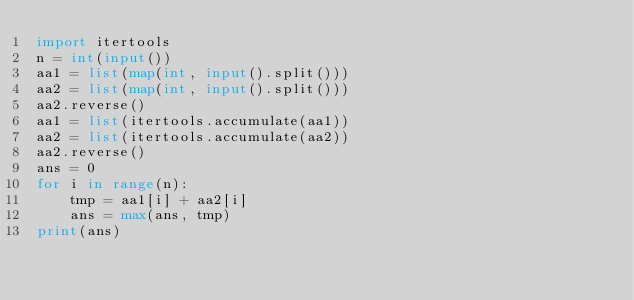Convert code to text. <code><loc_0><loc_0><loc_500><loc_500><_Python_>import itertools
n = int(input())
aa1 = list(map(int, input().split()))
aa2 = list(map(int, input().split()))
aa2.reverse()
aa1 = list(itertools.accumulate(aa1))
aa2 = list(itertools.accumulate(aa2))
aa2.reverse()
ans = 0
for i in range(n):
    tmp = aa1[i] + aa2[i]
    ans = max(ans, tmp)
print(ans)</code> 